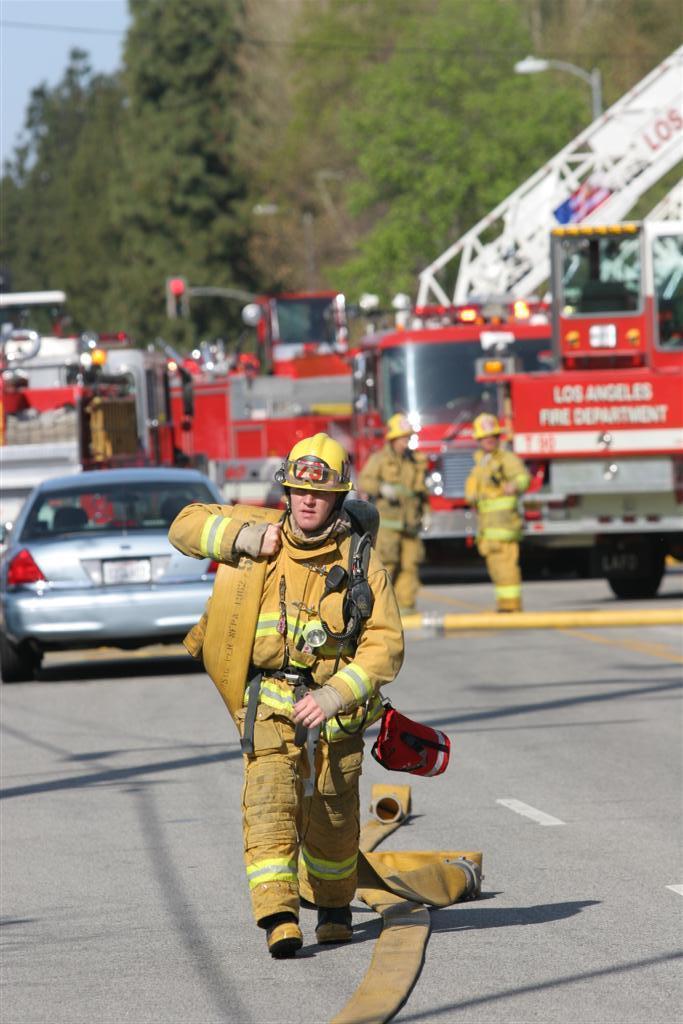Which fire department is that?
Offer a terse response. Los angeles. 